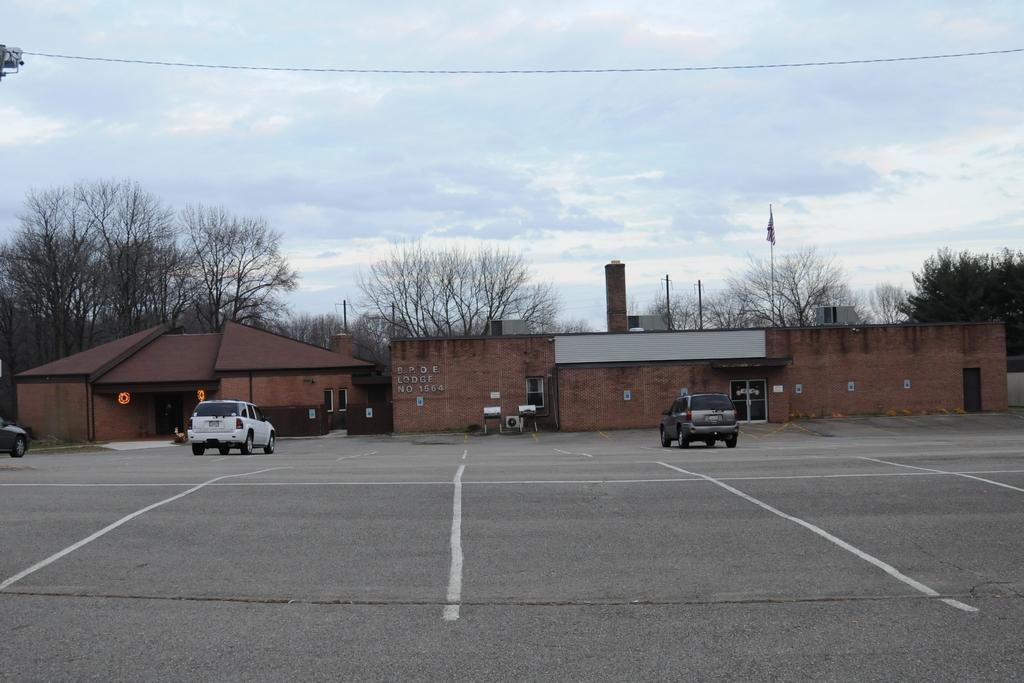What type of structure is present in the image? There is a shed in the image. What else can be seen in the image besides the shed? There are vehicles, poles, a flag, trees, and the sky visible in the image. What might the vehicles be used for? The vehicles in the image might be used for transportation or work purposes. What is attached to the poles in the image? The flag is attached to the poles in the image. What idea does the flag represent in the image? The image does not provide any information about the meaning or idea represented by the flag. How many children are playing in the image? There are no children present in the image. 